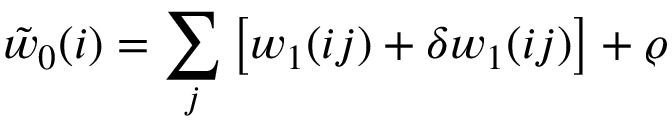Convert formula to latex. <formula><loc_0><loc_0><loc_500><loc_500>\tilde { w } _ { 0 } ( i ) = \sum _ { j } \left [ w _ { 1 } ( i j ) + \delta w _ { 1 } ( i j ) \right ] + \varrho</formula> 